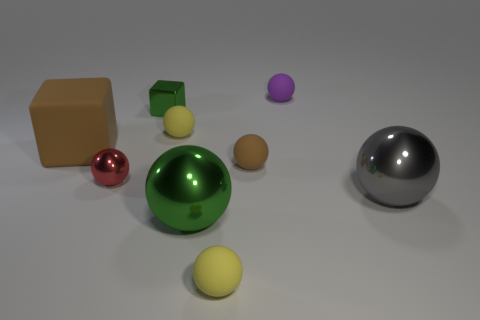There is a small sphere that is the same color as the big matte block; what material is it?
Offer a very short reply. Rubber. Does the rubber cube have the same size as the gray object?
Provide a short and direct response. Yes. Is the number of small balls that are in front of the tiny shiny sphere greater than the number of matte cylinders?
Ensure brevity in your answer.  Yes. There is a brown sphere that is the same size as the purple rubber thing; what material is it?
Provide a short and direct response. Rubber. Are there any balls of the same size as the gray metal thing?
Ensure brevity in your answer.  Yes. There is a sphere left of the small green shiny cube; what is its size?
Keep it short and to the point. Small. How big is the green metallic ball?
Your response must be concise. Large. How many balls are gray things or yellow rubber things?
Give a very brief answer. 3. What size is the green ball that is the same material as the red thing?
Your answer should be compact. Large. How many other cubes are the same color as the big rubber block?
Give a very brief answer. 0. 